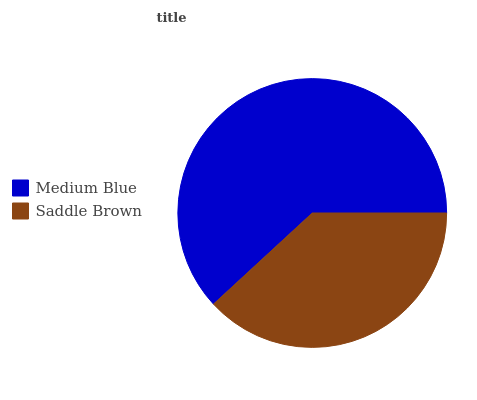Is Saddle Brown the minimum?
Answer yes or no. Yes. Is Medium Blue the maximum?
Answer yes or no. Yes. Is Saddle Brown the maximum?
Answer yes or no. No. Is Medium Blue greater than Saddle Brown?
Answer yes or no. Yes. Is Saddle Brown less than Medium Blue?
Answer yes or no. Yes. Is Saddle Brown greater than Medium Blue?
Answer yes or no. No. Is Medium Blue less than Saddle Brown?
Answer yes or no. No. Is Medium Blue the high median?
Answer yes or no. Yes. Is Saddle Brown the low median?
Answer yes or no. Yes. Is Saddle Brown the high median?
Answer yes or no. No. Is Medium Blue the low median?
Answer yes or no. No. 